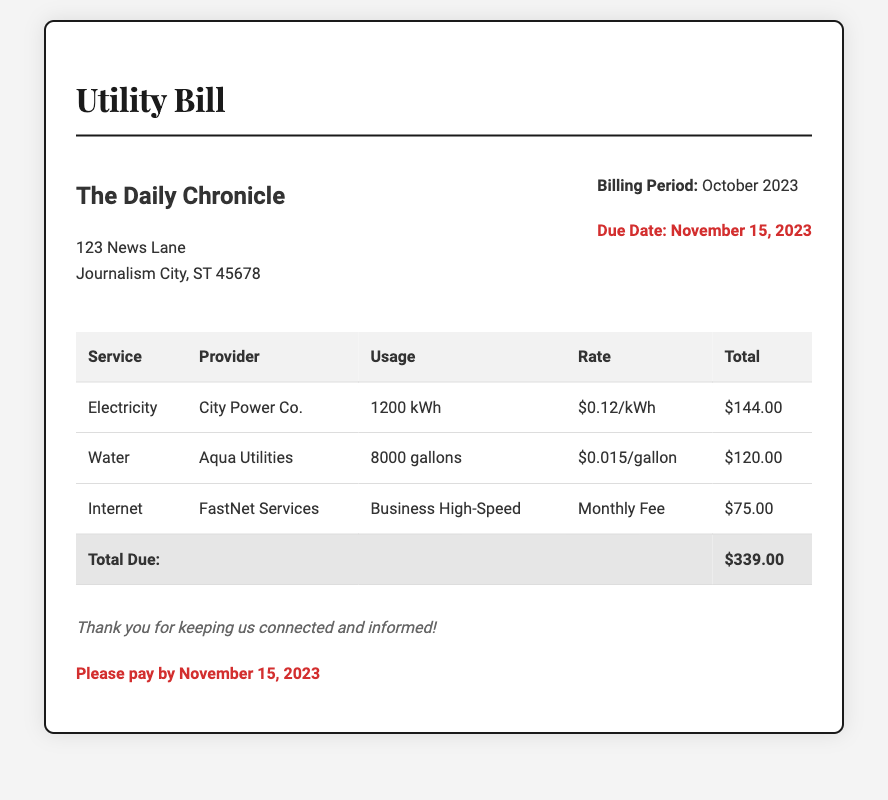What is the billing period? The billing period is specified in the document as the month it covers, which is October 2023.
Answer: October 2023 Who is the electricity provider? The document lists the service provider for electricity, which is stated clearly next to the electricity charges.
Answer: City Power Co What is the total amount due? The total amount due is given in a separate row at the bottom of the table, indicating the overall charges for the month.
Answer: $339.00 How much was charged for water usage? The document specifies the total amount charged for water in the respective row of the table under the Total column.
Answer: $120.00 What is the usage for internet service? The usage for internet service is specified in the table, indicating the plan that was used for the month.
Answer: Business High-Speed What is the due date for payment? The due date is clearly mentioned in the document, emphasizing the urgency for payment.
Answer: November 15, 2023 What is the rate per kilowatt-hour for electricity? The document provides the rate for electricity in the row where electricity service charges are listed.
Answer: $0.12/kWh How many gallons of water were used? The total amount of water usage for the billing period is specified in the water service row of the table.
Answer: 8000 gallons What is the monthly fee for internet service? The document categorizes internet service charges, indicating it as a fixed monthly fee.
Answer: $75.00 